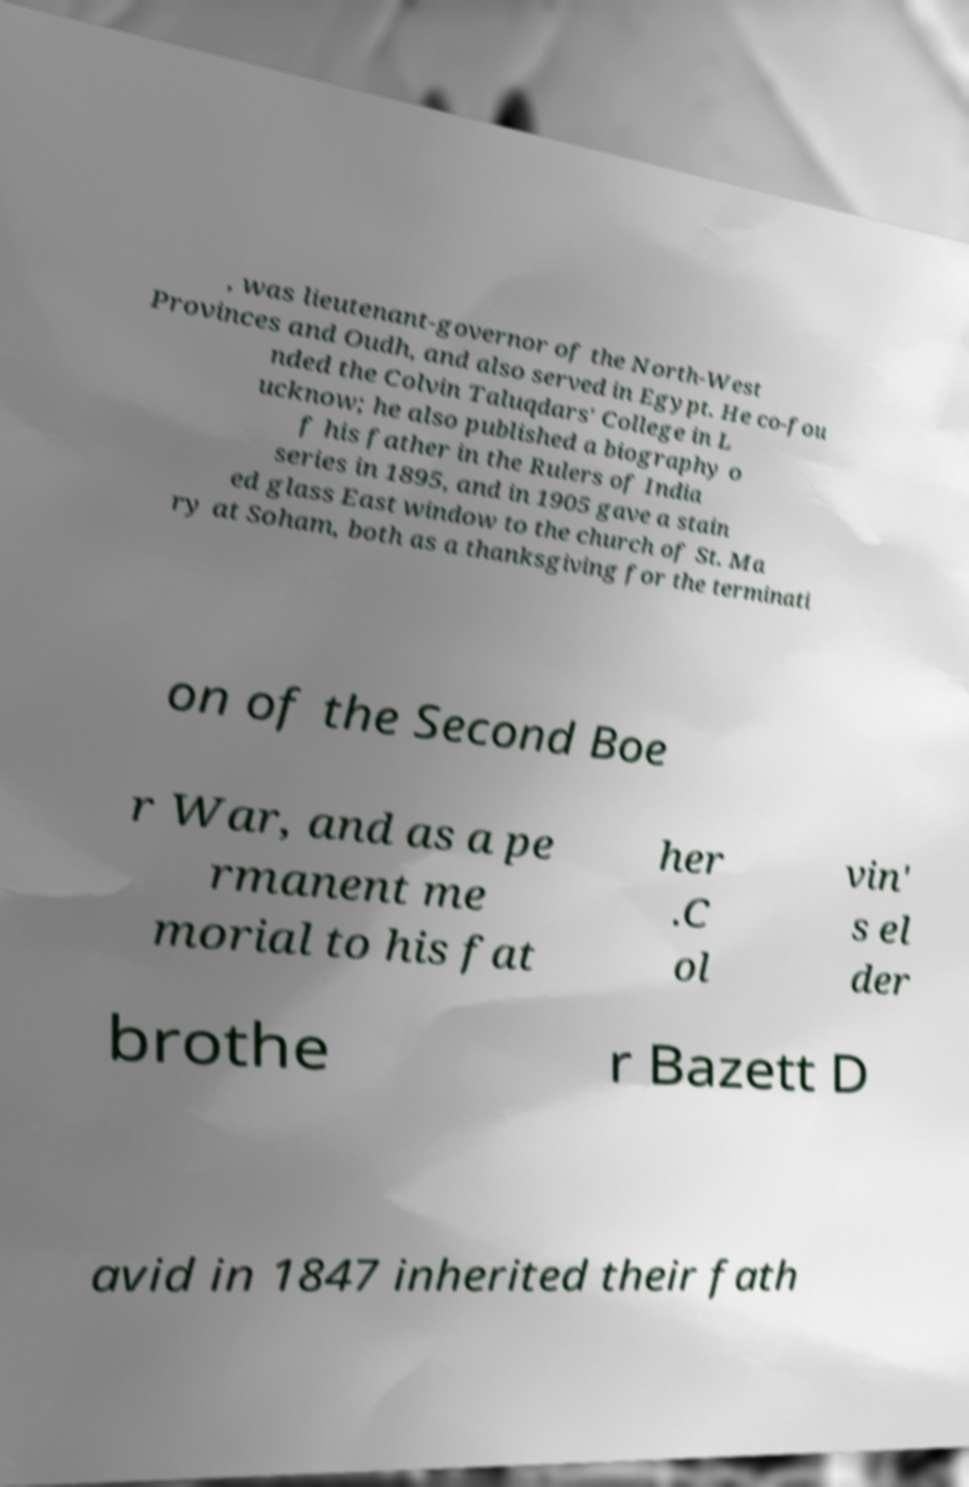Can you accurately transcribe the text from the provided image for me? , was lieutenant-governor of the North-West Provinces and Oudh, and also served in Egypt. He co-fou nded the Colvin Taluqdars' College in L ucknow; he also published a biography o f his father in the Rulers of India series in 1895, and in 1905 gave a stain ed glass East window to the church of St. Ma ry at Soham, both as a thanksgiving for the terminati on of the Second Boe r War, and as a pe rmanent me morial to his fat her .C ol vin' s el der brothe r Bazett D avid in 1847 inherited their fath 